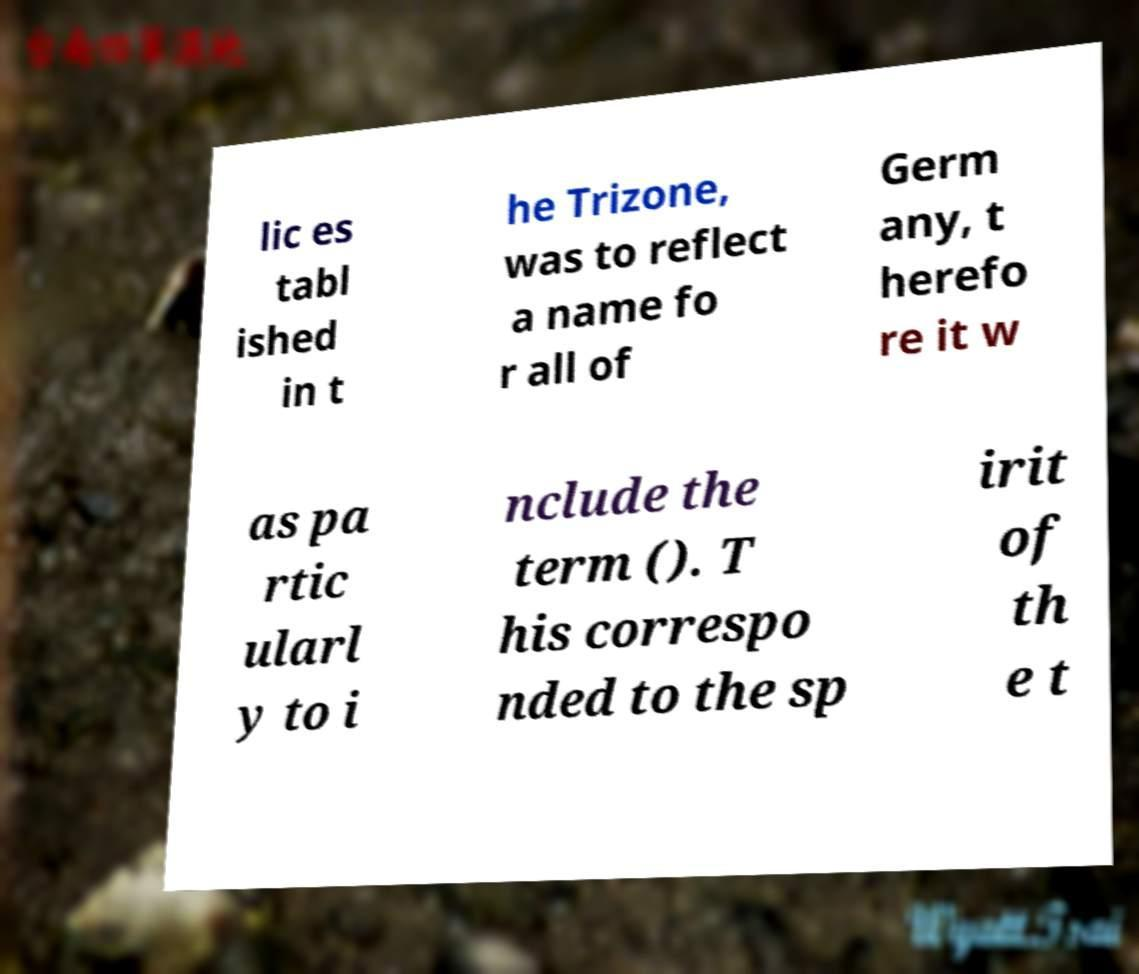Please read and relay the text visible in this image. What does it say? lic es tabl ished in t he Trizone, was to reflect a name fo r all of Germ any, t herefo re it w as pa rtic ularl y to i nclude the term (). T his correspo nded to the sp irit of th e t 